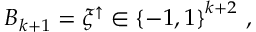<formula> <loc_0><loc_0><loc_500><loc_500>\begin{array} { r } { B _ { k + 1 } = \xi ^ { \uparrow } \in \left \{ - 1 , 1 \right \} ^ { k + 2 } \, , } \end{array}</formula> 